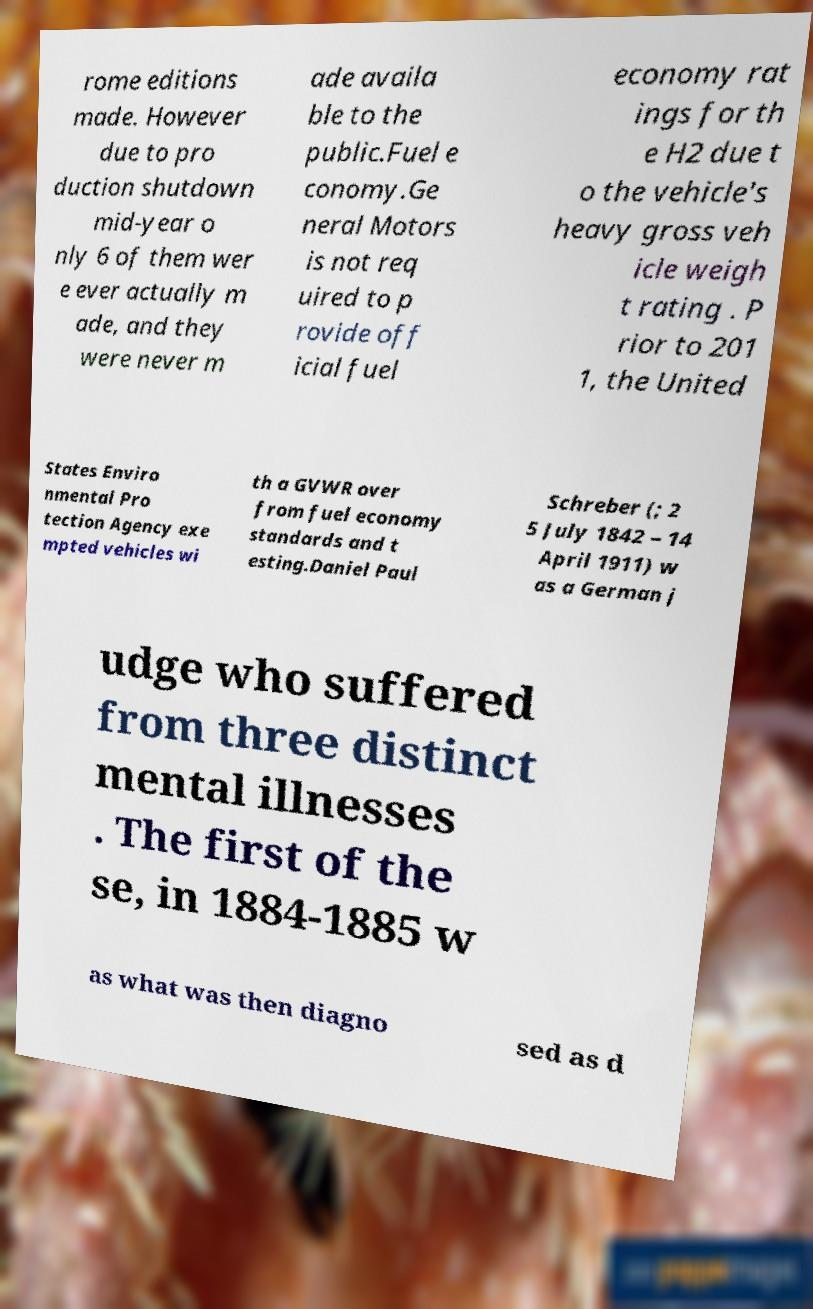For documentation purposes, I need the text within this image transcribed. Could you provide that? rome editions made. However due to pro duction shutdown mid-year o nly 6 of them wer e ever actually m ade, and they were never m ade availa ble to the public.Fuel e conomy.Ge neral Motors is not req uired to p rovide off icial fuel economy rat ings for th e H2 due t o the vehicle's heavy gross veh icle weigh t rating . P rior to 201 1, the United States Enviro nmental Pro tection Agency exe mpted vehicles wi th a GVWR over from fuel economy standards and t esting.Daniel Paul Schreber (; 2 5 July 1842 – 14 April 1911) w as a German j udge who suffered from three distinct mental illnesses . The first of the se, in 1884-1885 w as what was then diagno sed as d 